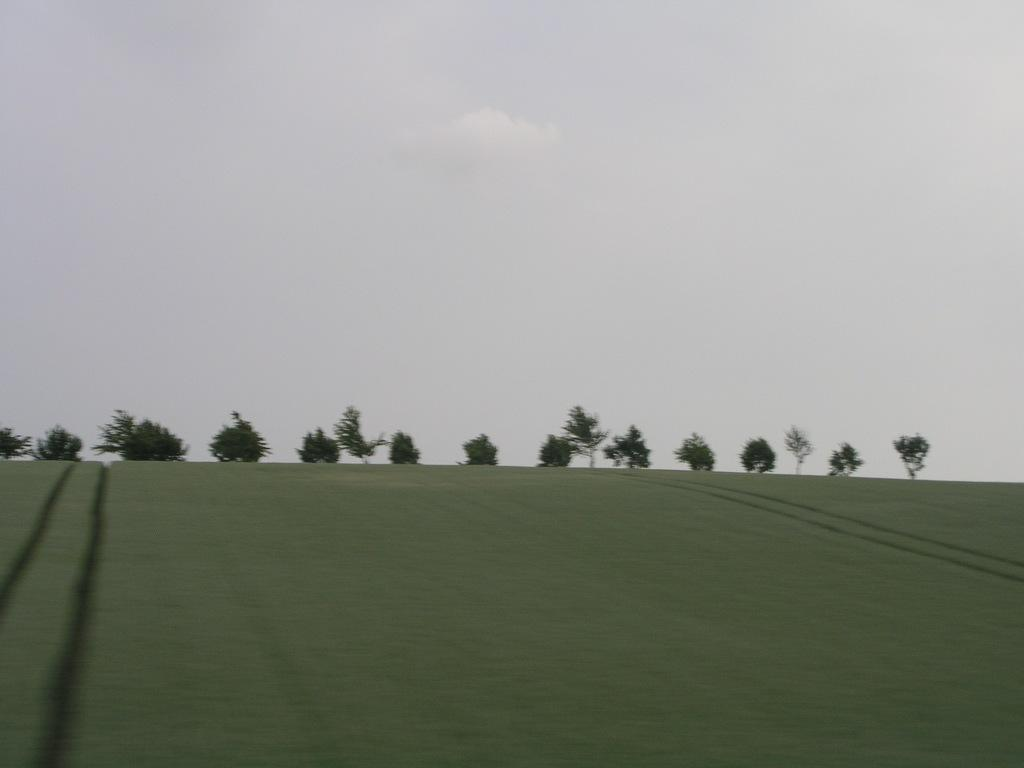What type of surface is visible in the image? There is ground visible in the image. What can be seen in the distance in the image? There are trees in the background of the image. What is visible at the top of the image? The sky is visible at the top of the image. What type of work is being done in the image? There is no indication of work being done in the image; it primarily features ground, trees, and the sky. Is there any sense of shame conveyed in the image? There is no indication of shame in the image; it is a simple depiction of ground, trees, and the sky. 